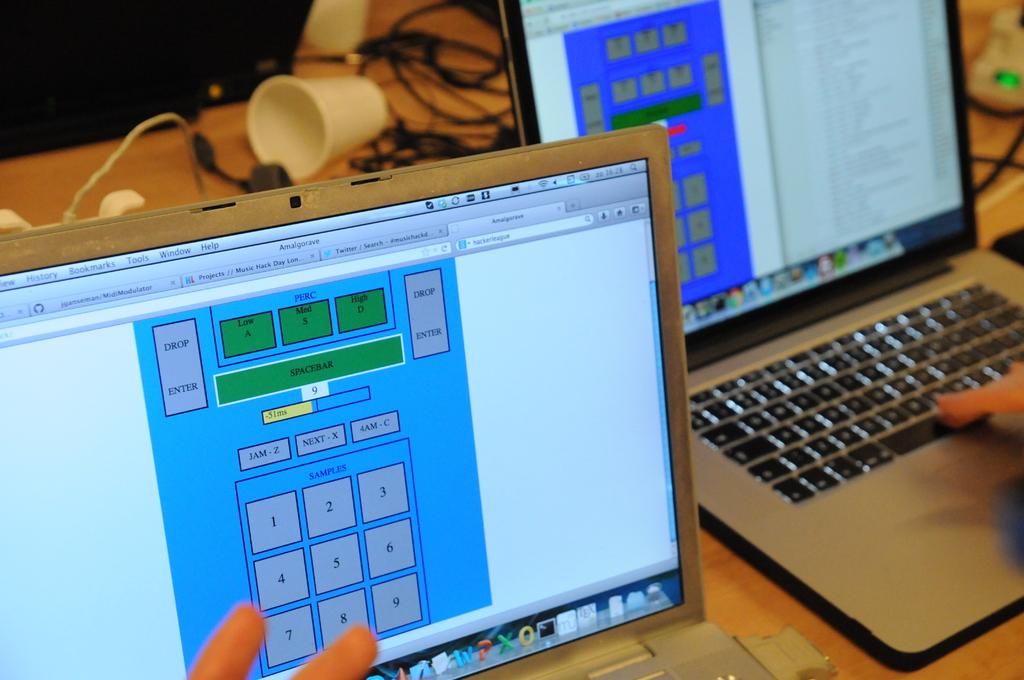What number is on the bottom right of the number pad?
Your response must be concise. 9. 